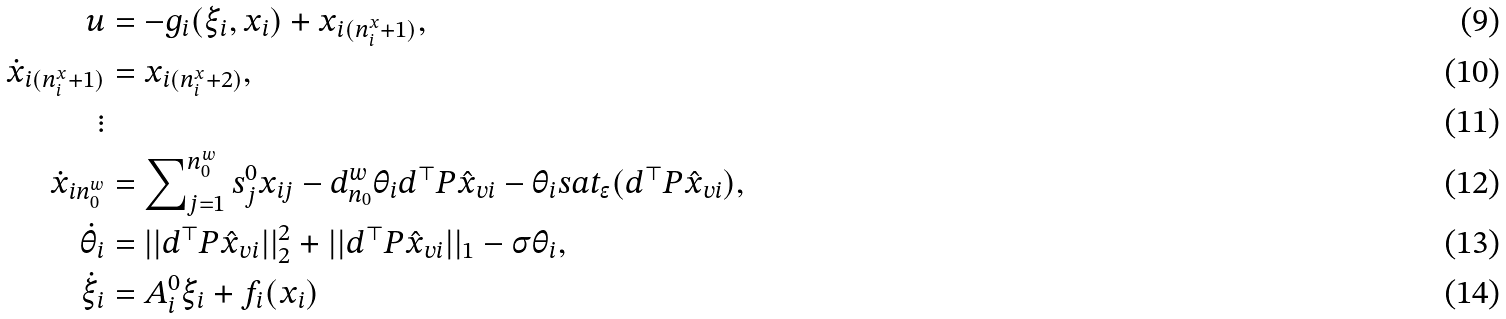Convert formula to latex. <formula><loc_0><loc_0><loc_500><loc_500>u & = - g _ { i } ( \xi _ { i } , x _ { i } ) + x _ { i ( n _ { i } ^ { x } + 1 ) } , \\ \dot { x } _ { i ( n _ { i } ^ { x } + 1 ) } & = x _ { i ( n _ { i } ^ { x } + 2 ) } , \\ \vdots \\ \dot { x } _ { i n _ { 0 } ^ { w } } & = \sum \nolimits _ { j = 1 } ^ { n _ { 0 } ^ { w } } s _ { j } ^ { 0 } x _ { i j } - d _ { n _ { 0 } } ^ { w } \theta _ { i } d ^ { \top } P \hat { x } _ { v i } - \theta _ { i } s a t _ { \epsilon } ( d ^ { \top } P \hat { x } _ { v i } ) , \\ \dot { \theta } _ { i } & = | | d ^ { \top } P \hat { x } _ { v i } | | _ { 2 } ^ { 2 } + | | d ^ { \top } P \hat { x } _ { v i } | | _ { 1 } - \sigma \theta _ { i } , \\ \dot { \xi } _ { i } & = A _ { i } ^ { 0 } \xi _ { i } + f _ { i } ( x _ { i } )</formula> 